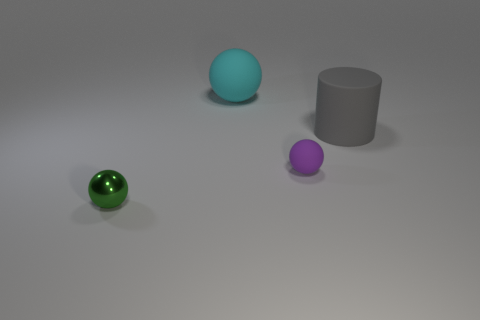Add 3 large rubber balls. How many objects exist? 7 Subtract all balls. How many objects are left? 1 Add 2 small yellow balls. How many small yellow balls exist? 2 Subtract 0 blue blocks. How many objects are left? 4 Subtract all large cylinders. Subtract all tiny brown matte cylinders. How many objects are left? 3 Add 2 large gray matte objects. How many large gray matte objects are left? 3 